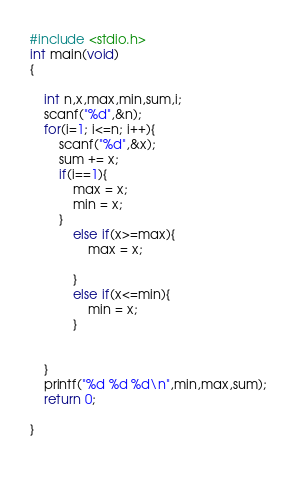<code> <loc_0><loc_0><loc_500><loc_500><_C_>#include <stdio.h>
int main(void)
{
   
    int n,x,max,min,sum,i;
    scanf("%d",&n);
    for(i=1; i<=n; i++){
        scanf("%d",&x);
        sum += x;
        if(i==1){
            max = x;
            min = x;
        }
            else if(x>=max){
                max = x;
            
            }
            else if(x<=min){
                min = x;
            }
        
        
    }
    printf("%d %d %d\n",min,max,sum);
    return 0;
    
}

    


</code> 